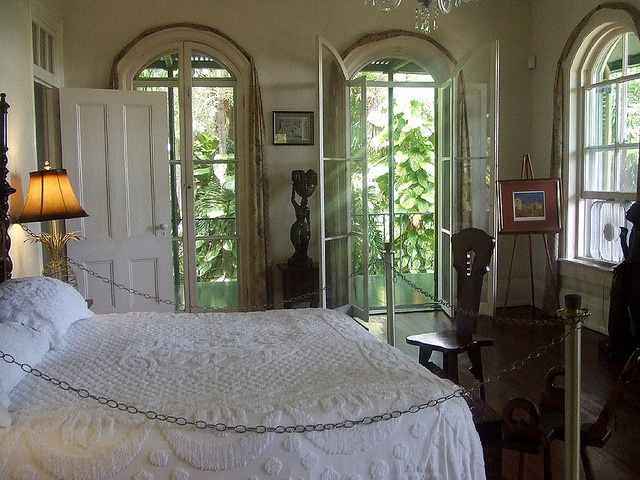Describe the objects in this image and their specific colors. I can see bed in gray tones and chair in gray, black, lightgray, and darkgray tones in this image. 